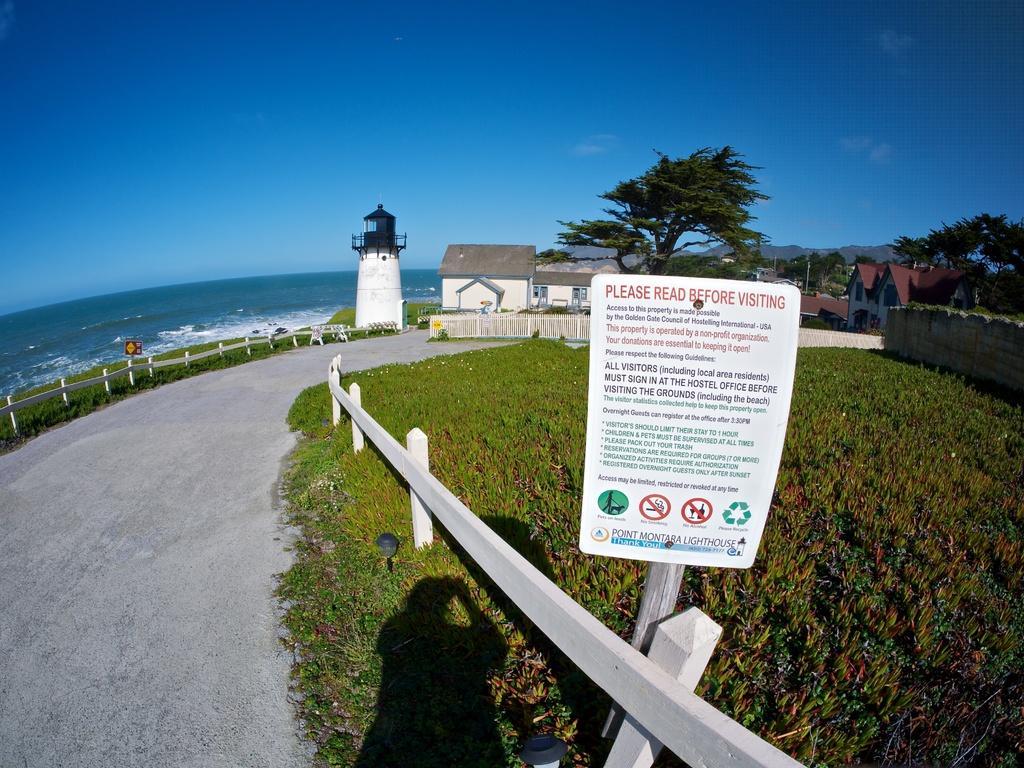Could you give a brief overview of what you see in this image? In this image, we can see houses, trees, poles, boards, a chimney and we can see fences and at the bottom, there is water and a road. 